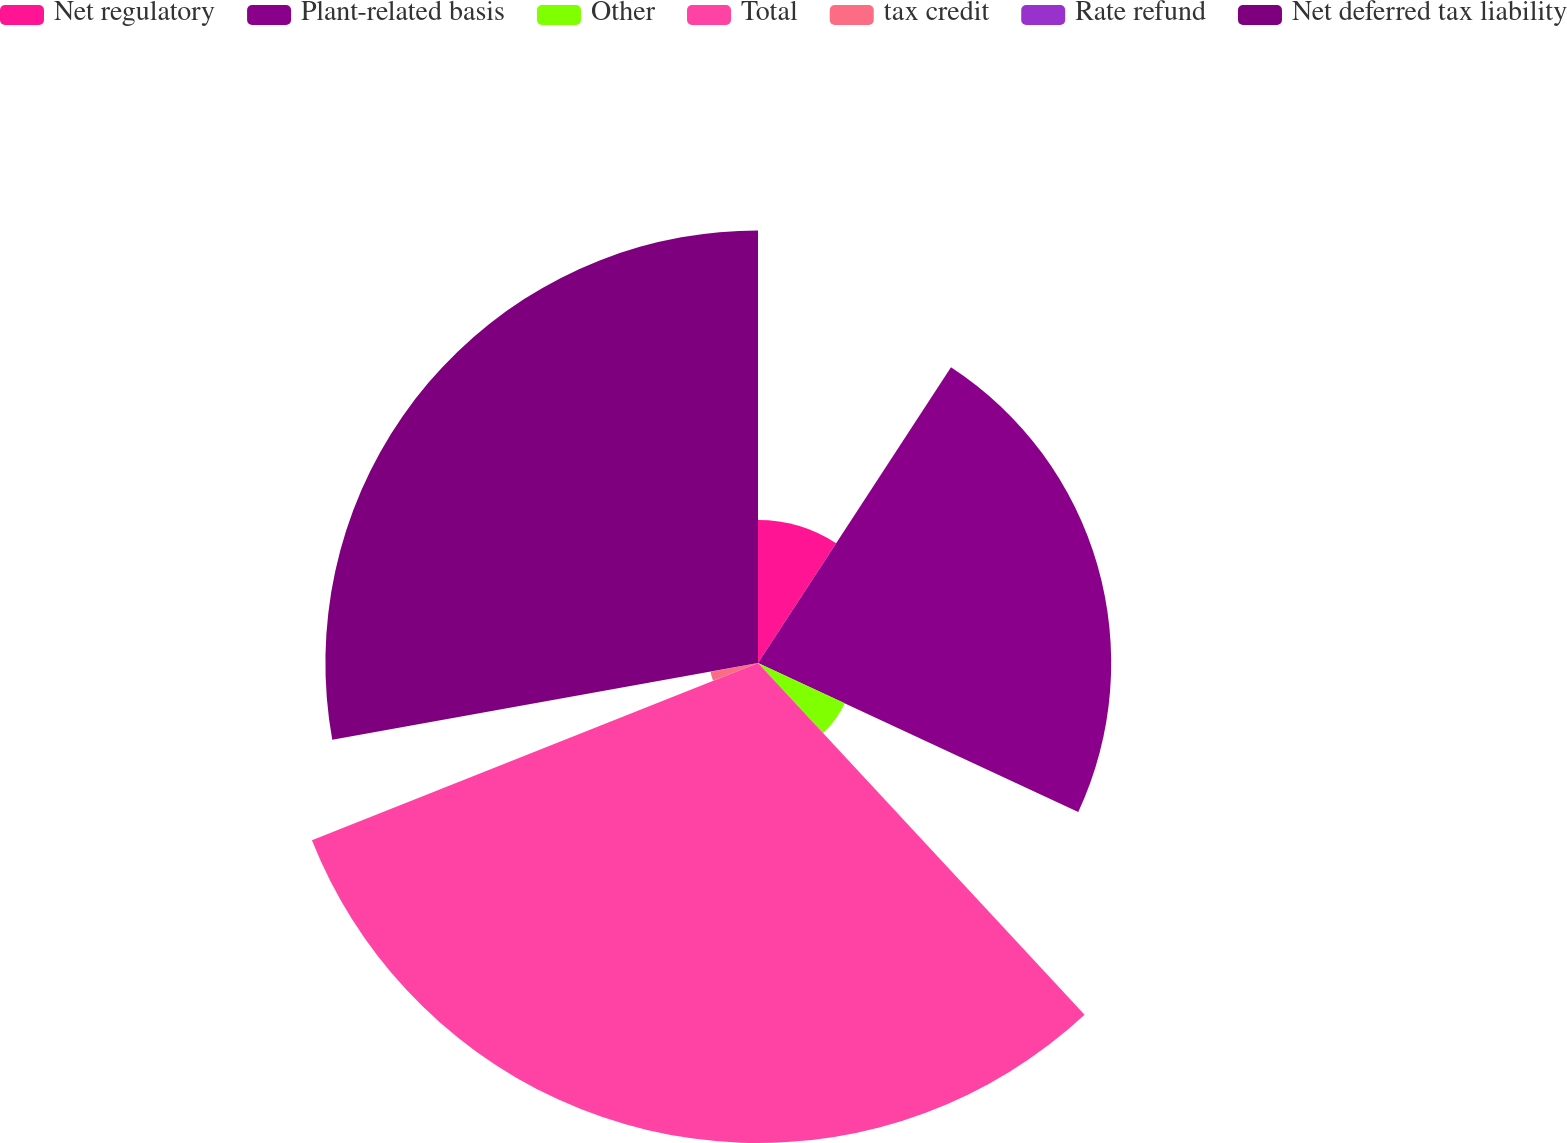Convert chart to OTSL. <chart><loc_0><loc_0><loc_500><loc_500><pie_chart><fcel>Net regulatory<fcel>Plant-related basis<fcel>Other<fcel>Total<fcel>tax credit<fcel>Rate refund<fcel>Net deferred tax liability<nl><fcel>9.2%<fcel>22.73%<fcel>6.16%<fcel>30.89%<fcel>3.11%<fcel>0.07%<fcel>27.84%<nl></chart> 